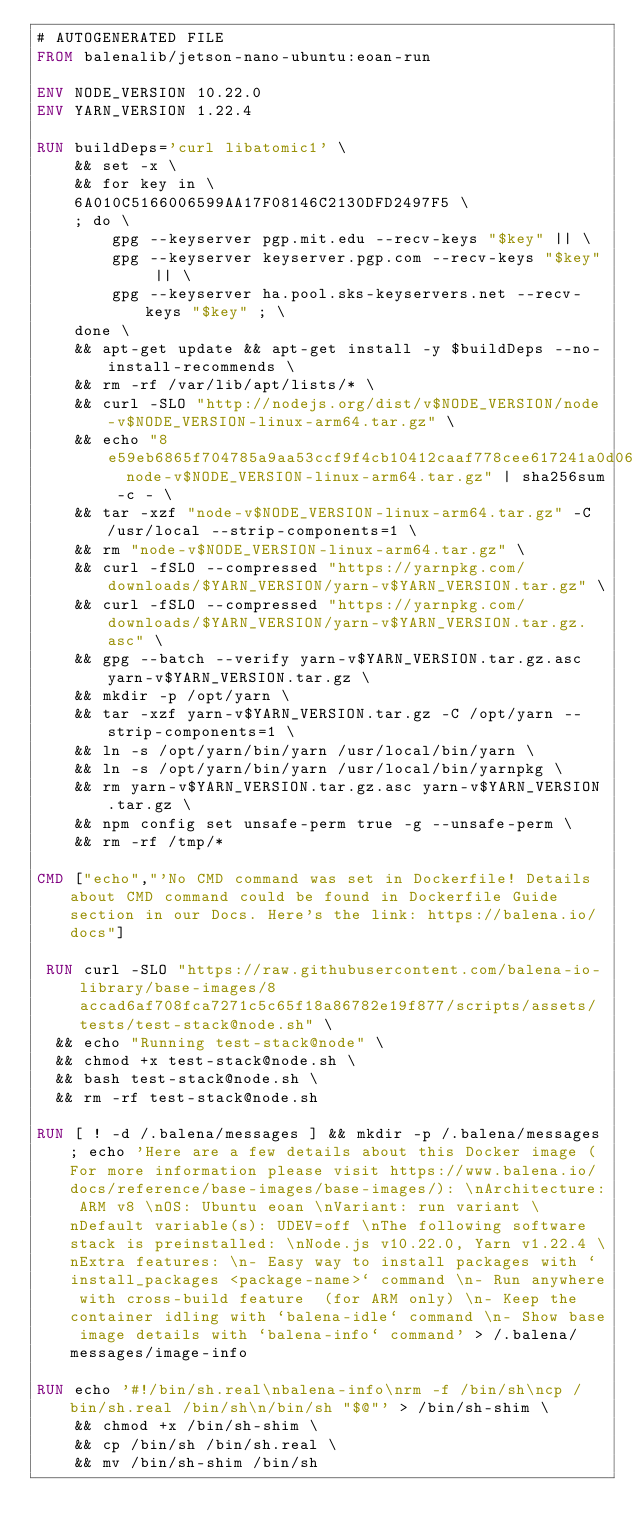Convert code to text. <code><loc_0><loc_0><loc_500><loc_500><_Dockerfile_># AUTOGENERATED FILE
FROM balenalib/jetson-nano-ubuntu:eoan-run

ENV NODE_VERSION 10.22.0
ENV YARN_VERSION 1.22.4

RUN buildDeps='curl libatomic1' \
	&& set -x \
	&& for key in \
	6A010C5166006599AA17F08146C2130DFD2497F5 \
	; do \
		gpg --keyserver pgp.mit.edu --recv-keys "$key" || \
		gpg --keyserver keyserver.pgp.com --recv-keys "$key" || \
		gpg --keyserver ha.pool.sks-keyservers.net --recv-keys "$key" ; \
	done \
	&& apt-get update && apt-get install -y $buildDeps --no-install-recommends \
	&& rm -rf /var/lib/apt/lists/* \
	&& curl -SLO "http://nodejs.org/dist/v$NODE_VERSION/node-v$NODE_VERSION-linux-arm64.tar.gz" \
	&& echo "8e59eb6865f704785a9aa53ccf9f4cb10412caaf778cee617241a0d0684e008d  node-v$NODE_VERSION-linux-arm64.tar.gz" | sha256sum -c - \
	&& tar -xzf "node-v$NODE_VERSION-linux-arm64.tar.gz" -C /usr/local --strip-components=1 \
	&& rm "node-v$NODE_VERSION-linux-arm64.tar.gz" \
	&& curl -fSLO --compressed "https://yarnpkg.com/downloads/$YARN_VERSION/yarn-v$YARN_VERSION.tar.gz" \
	&& curl -fSLO --compressed "https://yarnpkg.com/downloads/$YARN_VERSION/yarn-v$YARN_VERSION.tar.gz.asc" \
	&& gpg --batch --verify yarn-v$YARN_VERSION.tar.gz.asc yarn-v$YARN_VERSION.tar.gz \
	&& mkdir -p /opt/yarn \
	&& tar -xzf yarn-v$YARN_VERSION.tar.gz -C /opt/yarn --strip-components=1 \
	&& ln -s /opt/yarn/bin/yarn /usr/local/bin/yarn \
	&& ln -s /opt/yarn/bin/yarn /usr/local/bin/yarnpkg \
	&& rm yarn-v$YARN_VERSION.tar.gz.asc yarn-v$YARN_VERSION.tar.gz \
	&& npm config set unsafe-perm true -g --unsafe-perm \
	&& rm -rf /tmp/*

CMD ["echo","'No CMD command was set in Dockerfile! Details about CMD command could be found in Dockerfile Guide section in our Docs. Here's the link: https://balena.io/docs"]

 RUN curl -SLO "https://raw.githubusercontent.com/balena-io-library/base-images/8accad6af708fca7271c5c65f18a86782e19f877/scripts/assets/tests/test-stack@node.sh" \
  && echo "Running test-stack@node" \
  && chmod +x test-stack@node.sh \
  && bash test-stack@node.sh \
  && rm -rf test-stack@node.sh 

RUN [ ! -d /.balena/messages ] && mkdir -p /.balena/messages; echo 'Here are a few details about this Docker image (For more information please visit https://www.balena.io/docs/reference/base-images/base-images/): \nArchitecture: ARM v8 \nOS: Ubuntu eoan \nVariant: run variant \nDefault variable(s): UDEV=off \nThe following software stack is preinstalled: \nNode.js v10.22.0, Yarn v1.22.4 \nExtra features: \n- Easy way to install packages with `install_packages <package-name>` command \n- Run anywhere with cross-build feature  (for ARM only) \n- Keep the container idling with `balena-idle` command \n- Show base image details with `balena-info` command' > /.balena/messages/image-info

RUN echo '#!/bin/sh.real\nbalena-info\nrm -f /bin/sh\ncp /bin/sh.real /bin/sh\n/bin/sh "$@"' > /bin/sh-shim \
	&& chmod +x /bin/sh-shim \
	&& cp /bin/sh /bin/sh.real \
	&& mv /bin/sh-shim /bin/sh</code> 